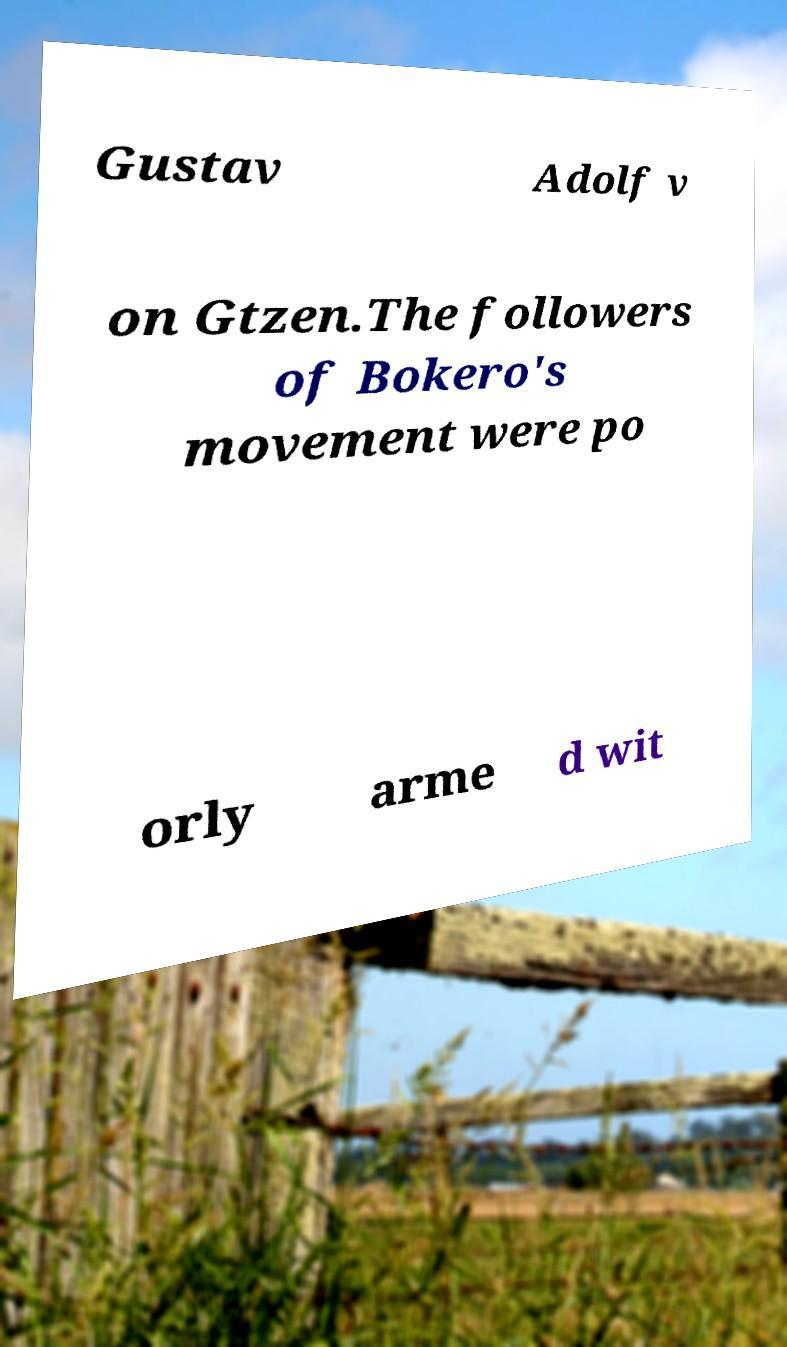Please read and relay the text visible in this image. What does it say? Gustav Adolf v on Gtzen.The followers of Bokero's movement were po orly arme d wit 